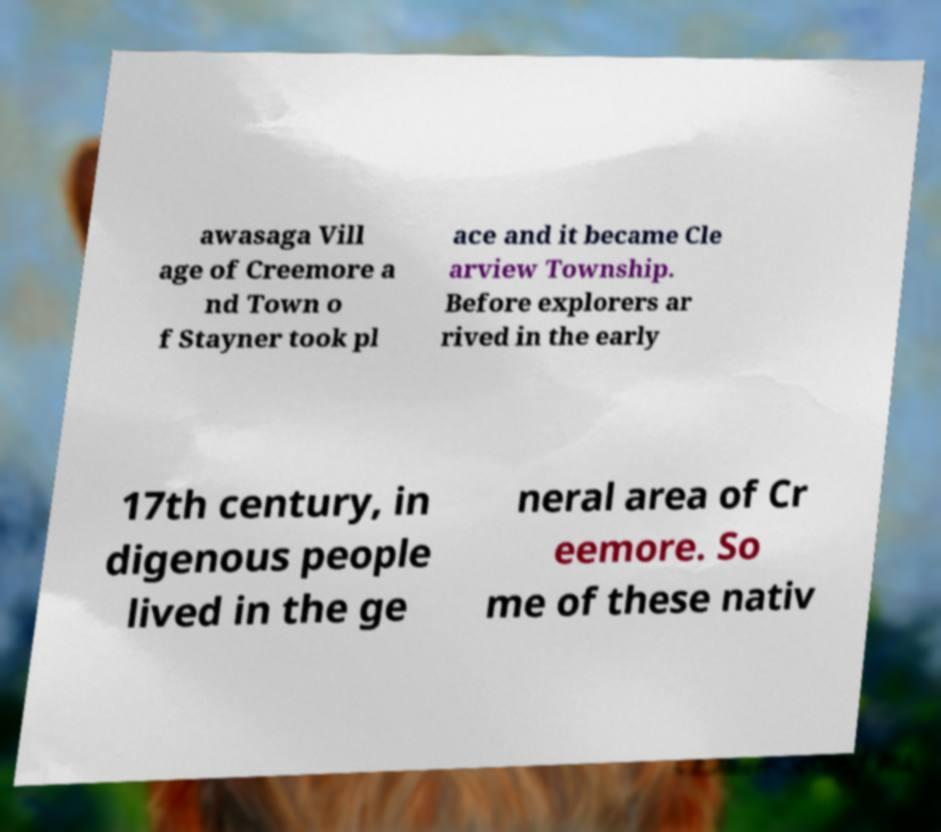Could you extract and type out the text from this image? awasaga Vill age of Creemore a nd Town o f Stayner took pl ace and it became Cle arview Township. Before explorers ar rived in the early 17th century, in digenous people lived in the ge neral area of Cr eemore. So me of these nativ 